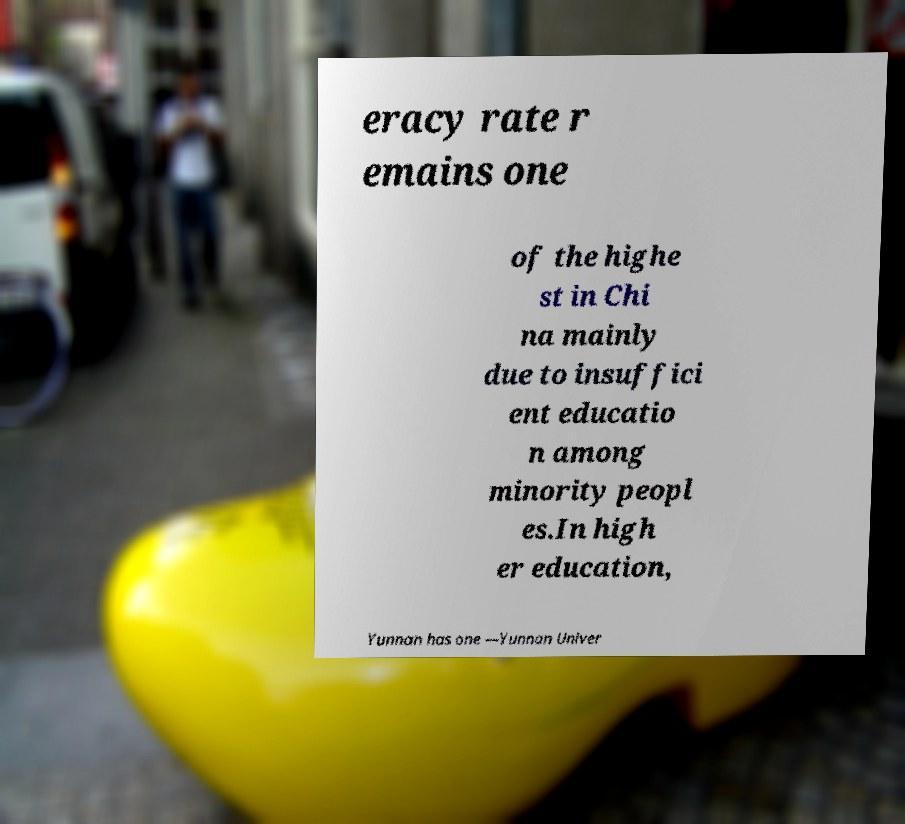Can you accurately transcribe the text from the provided image for me? eracy rate r emains one of the highe st in Chi na mainly due to insuffici ent educatio n among minority peopl es.In high er education, Yunnan has one —Yunnan Univer 